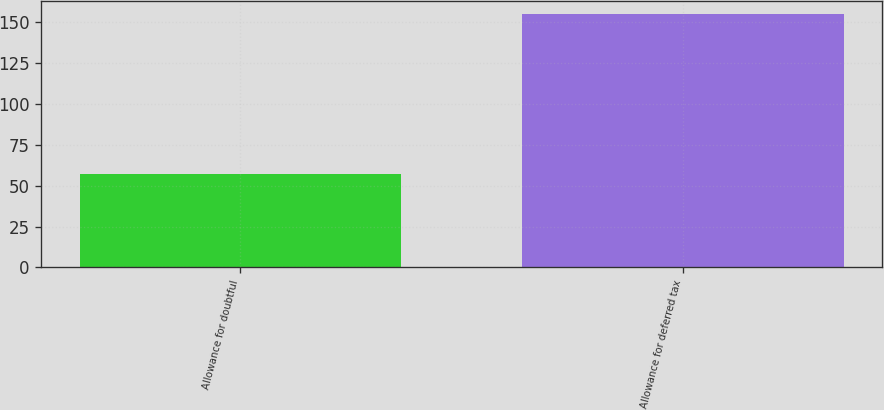<chart> <loc_0><loc_0><loc_500><loc_500><bar_chart><fcel>Allowance for doubtful<fcel>Allowance for deferred tax<nl><fcel>57<fcel>155<nl></chart> 